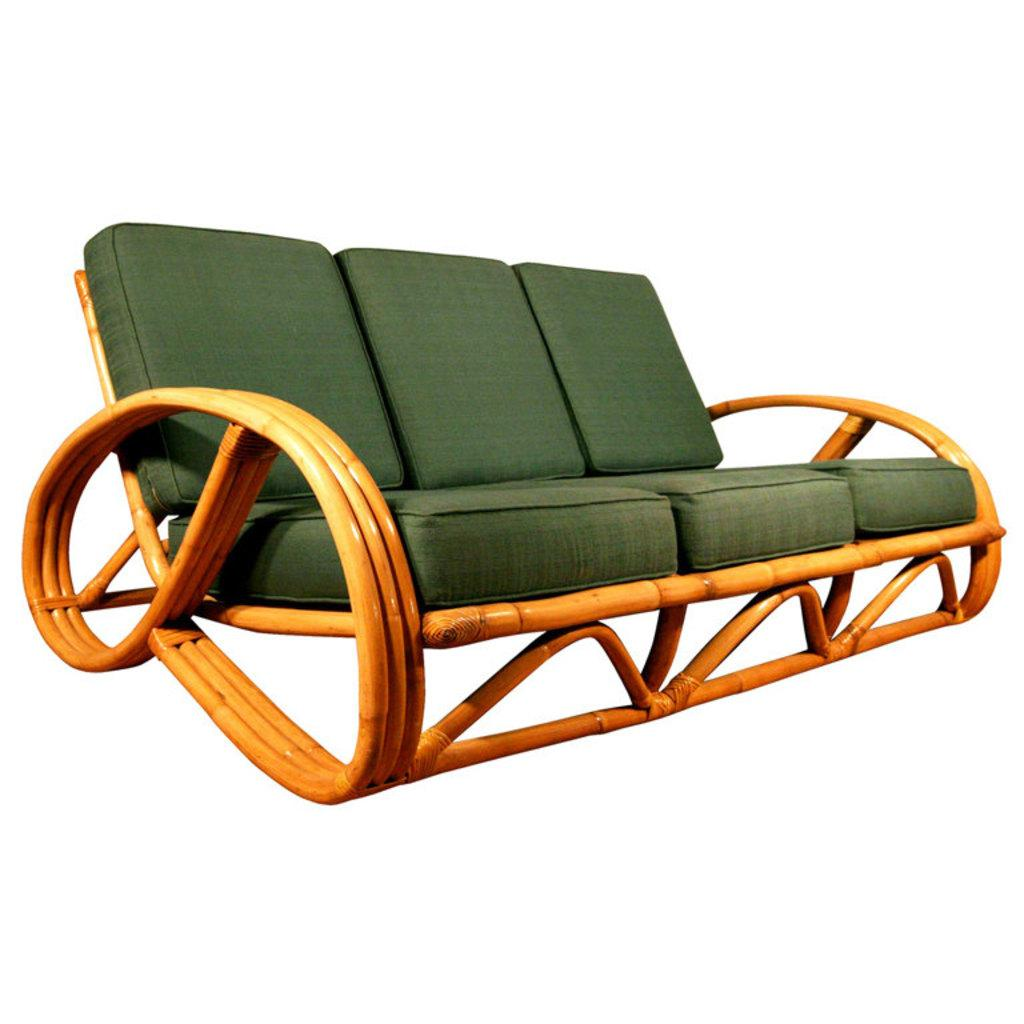What type of furniture is in the image? There is a wooden couch in the image. What color are the cushions on the couch? The cushions on the couch are green. What color is the background of the image? The background of the image is white. What type of coal is visible on the couch in the image? There is no coal present in the image; it features a wooden couch with green cushions against a white background. 